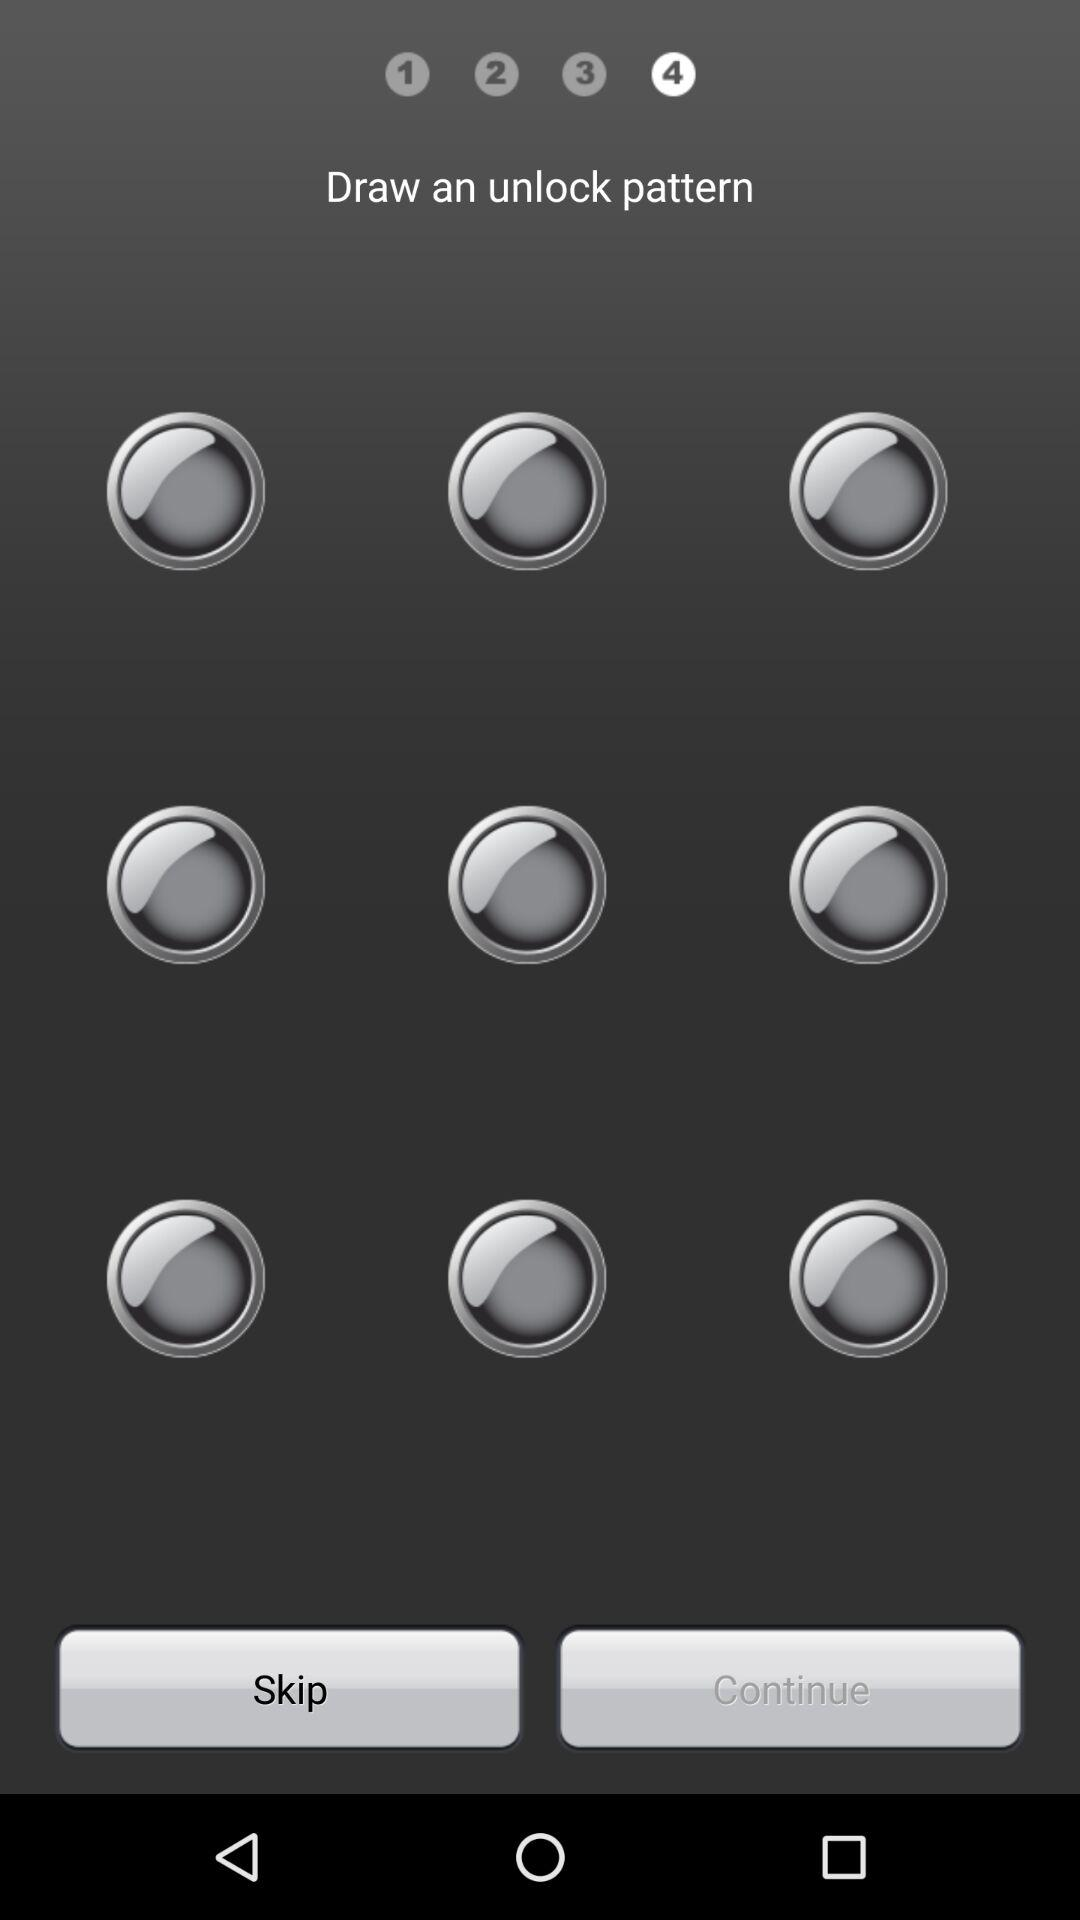On which step am I? You are on the fourth step. 